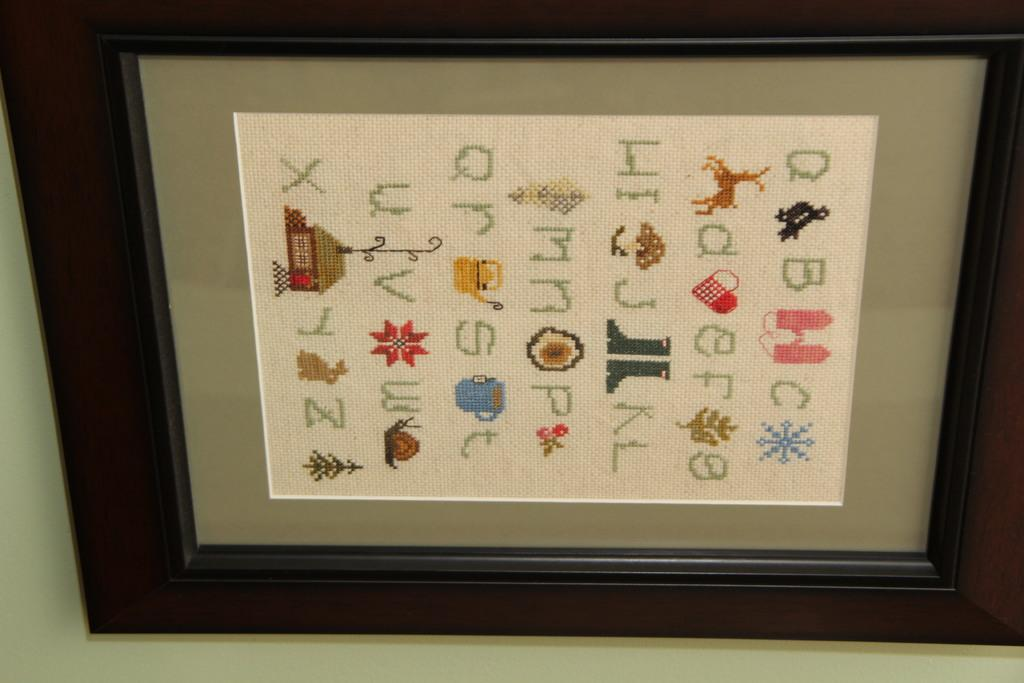<image>
Summarize the visual content of the image. A frame with knitted letters and images to show the alphabet. 